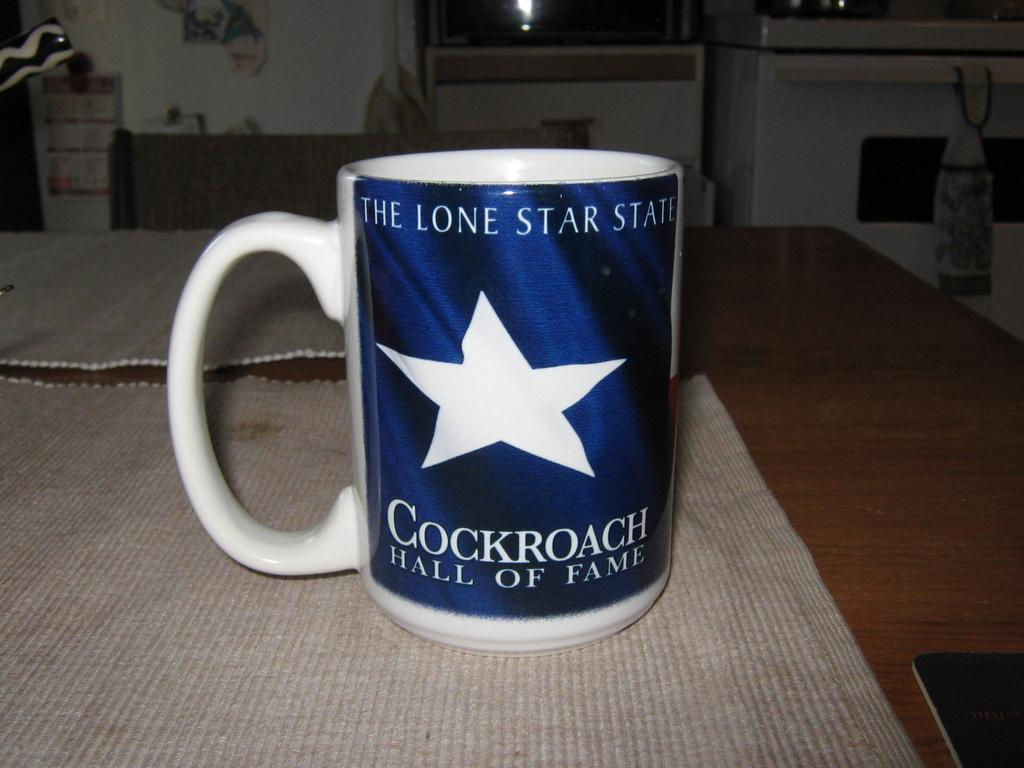Provide a one-sentence caption for the provided image. A coffee cup is labeled with Cockroach Hall of Fame. 